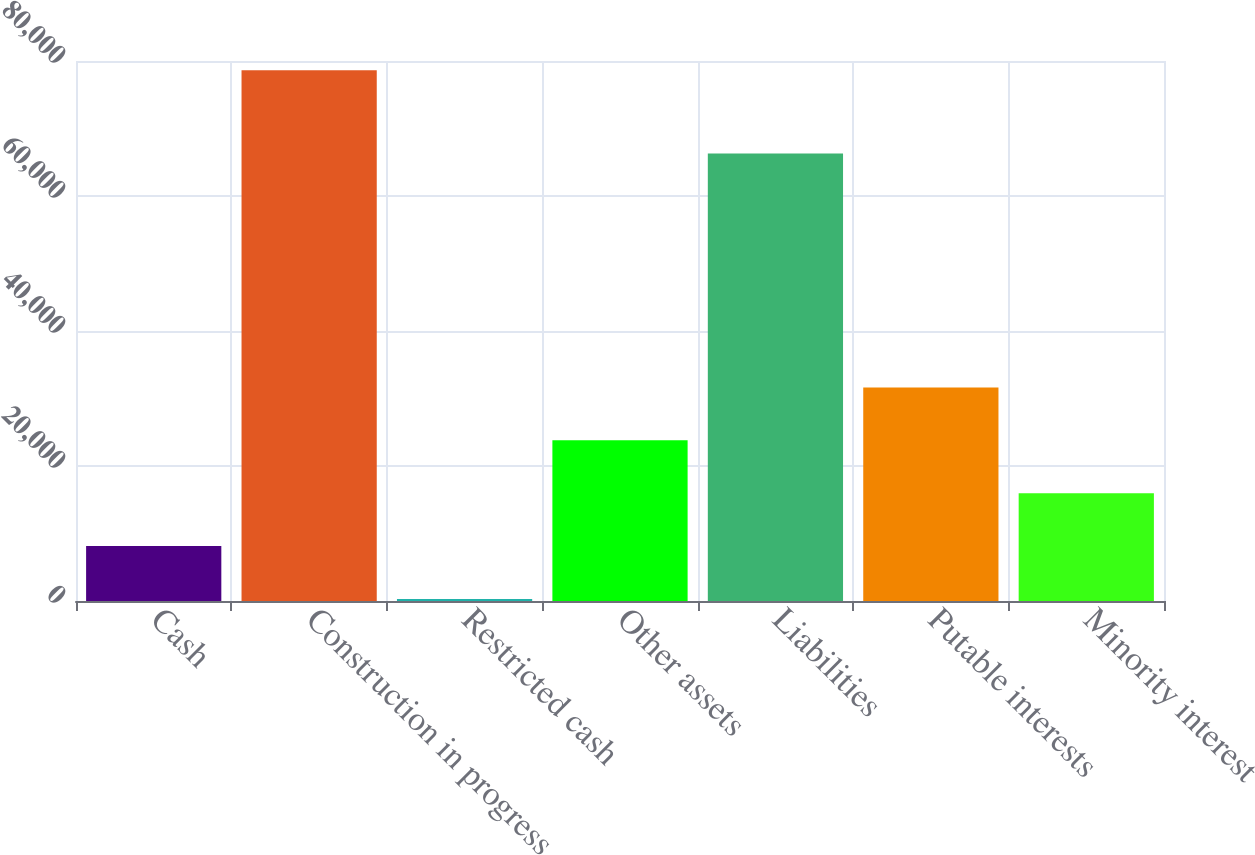Convert chart to OTSL. <chart><loc_0><loc_0><loc_500><loc_500><bar_chart><fcel>Cash<fcel>Construction in progress<fcel>Restricted cash<fcel>Other assets<fcel>Liabilities<fcel>Putable interests<fcel>Minority interest<nl><fcel>8138.4<fcel>78621<fcel>307<fcel>23801.2<fcel>66287<fcel>31632.6<fcel>15969.8<nl></chart> 